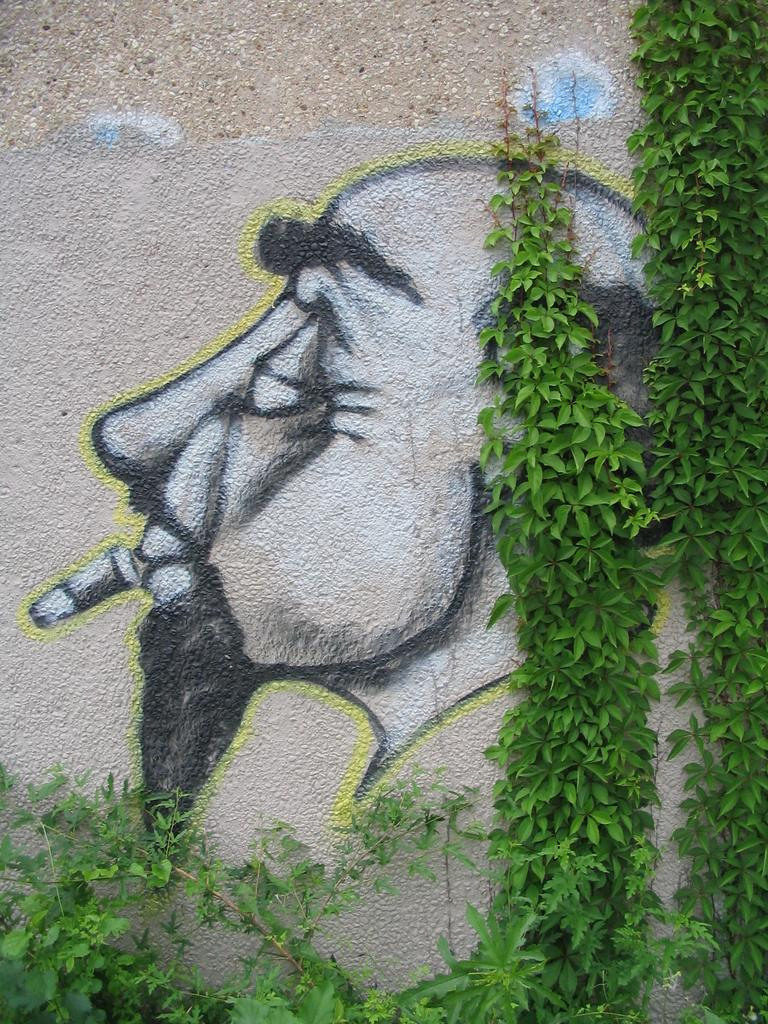What is depicted on the wall in the center of the image? There is graffiti on a wall in the center of the image. What can be seen on the right side of the image? There are plants on the right side of the image. How many horses are depicted in the graffiti on the wall? There are no horses depicted in the graffiti on the wall; the image only shows graffiti and plants. 